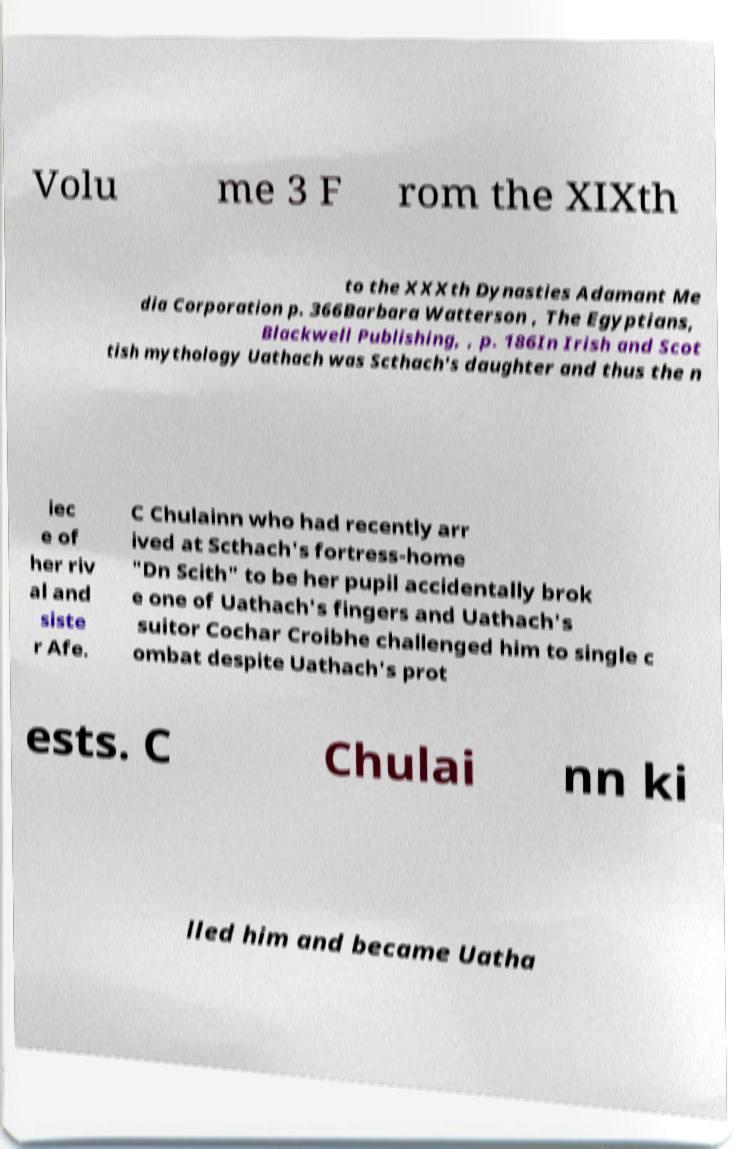For documentation purposes, I need the text within this image transcribed. Could you provide that? Volu me 3 F rom the XIXth to the XXXth Dynasties Adamant Me dia Corporation p. 366Barbara Watterson , The Egyptians, Blackwell Publishing, , p. 186In Irish and Scot tish mythology Uathach was Scthach's daughter and thus the n iec e of her riv al and siste r Afe. C Chulainn who had recently arr ived at Scthach's fortress-home "Dn Scith" to be her pupil accidentally brok e one of Uathach's fingers and Uathach's suitor Cochar Croibhe challenged him to single c ombat despite Uathach's prot ests. C Chulai nn ki lled him and became Uatha 